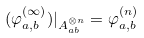Convert formula to latex. <formula><loc_0><loc_0><loc_500><loc_500>( \varphi _ { a , b } ^ { ( \infty ) } ) | _ { A _ { a b } ^ { \otimes n } } = \varphi _ { a , b } ^ { ( n ) }</formula> 